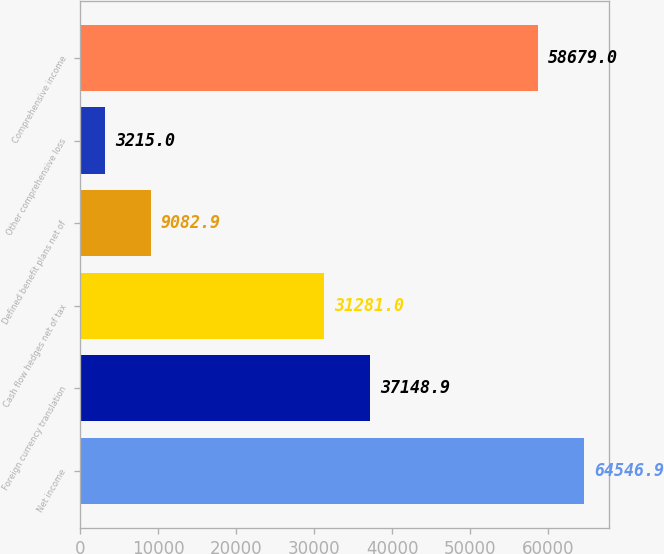Convert chart to OTSL. <chart><loc_0><loc_0><loc_500><loc_500><bar_chart><fcel>Net income<fcel>Foreign currency translation<fcel>Cash flow hedges net of tax<fcel>Defined benefit plans net of<fcel>Other comprehensive loss<fcel>Comprehensive income<nl><fcel>64546.9<fcel>37148.9<fcel>31281<fcel>9082.9<fcel>3215<fcel>58679<nl></chart> 